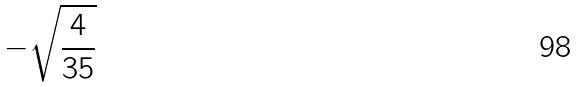Convert formula to latex. <formula><loc_0><loc_0><loc_500><loc_500>- \sqrt { \frac { 4 } { 3 5 } }</formula> 